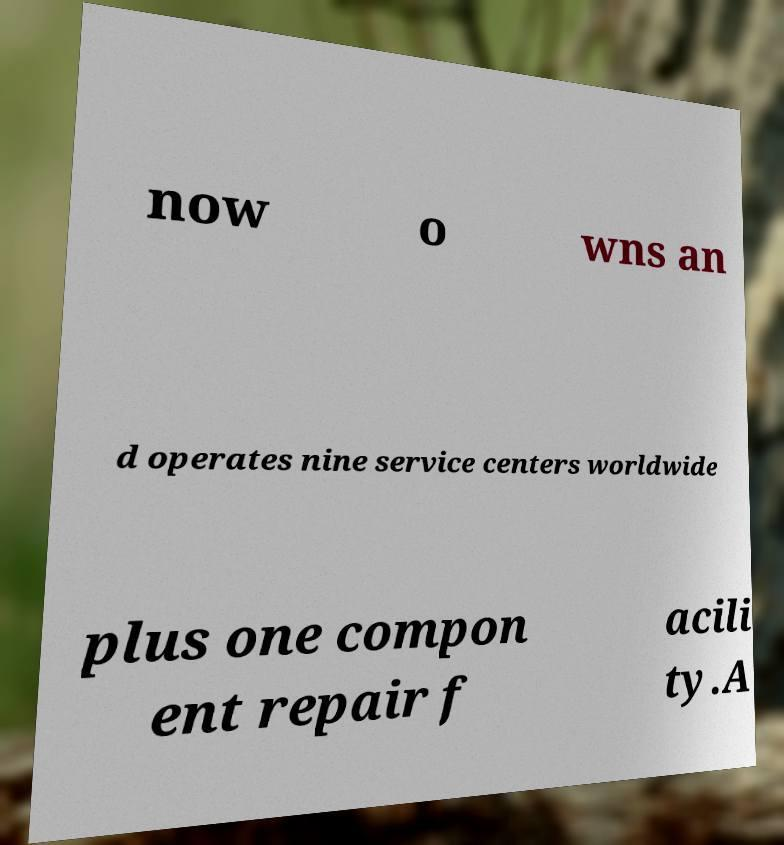Can you accurately transcribe the text from the provided image for me? now o wns an d operates nine service centers worldwide plus one compon ent repair f acili ty.A 